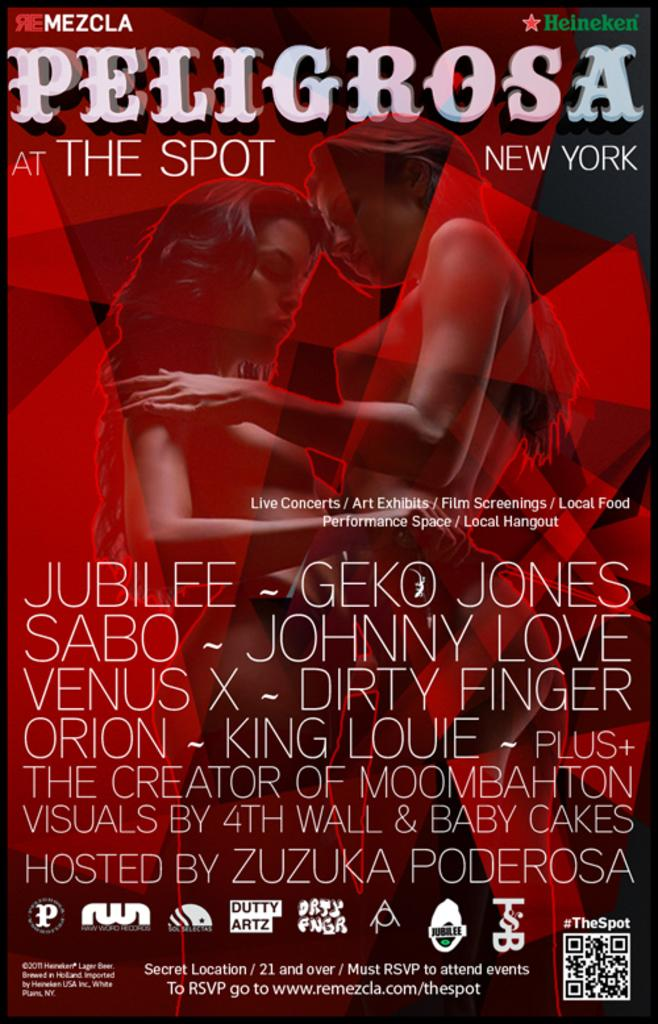<image>
Create a compact narrative representing the image presented. Heineken sponsored a music and arts show at The Spot in New York. 